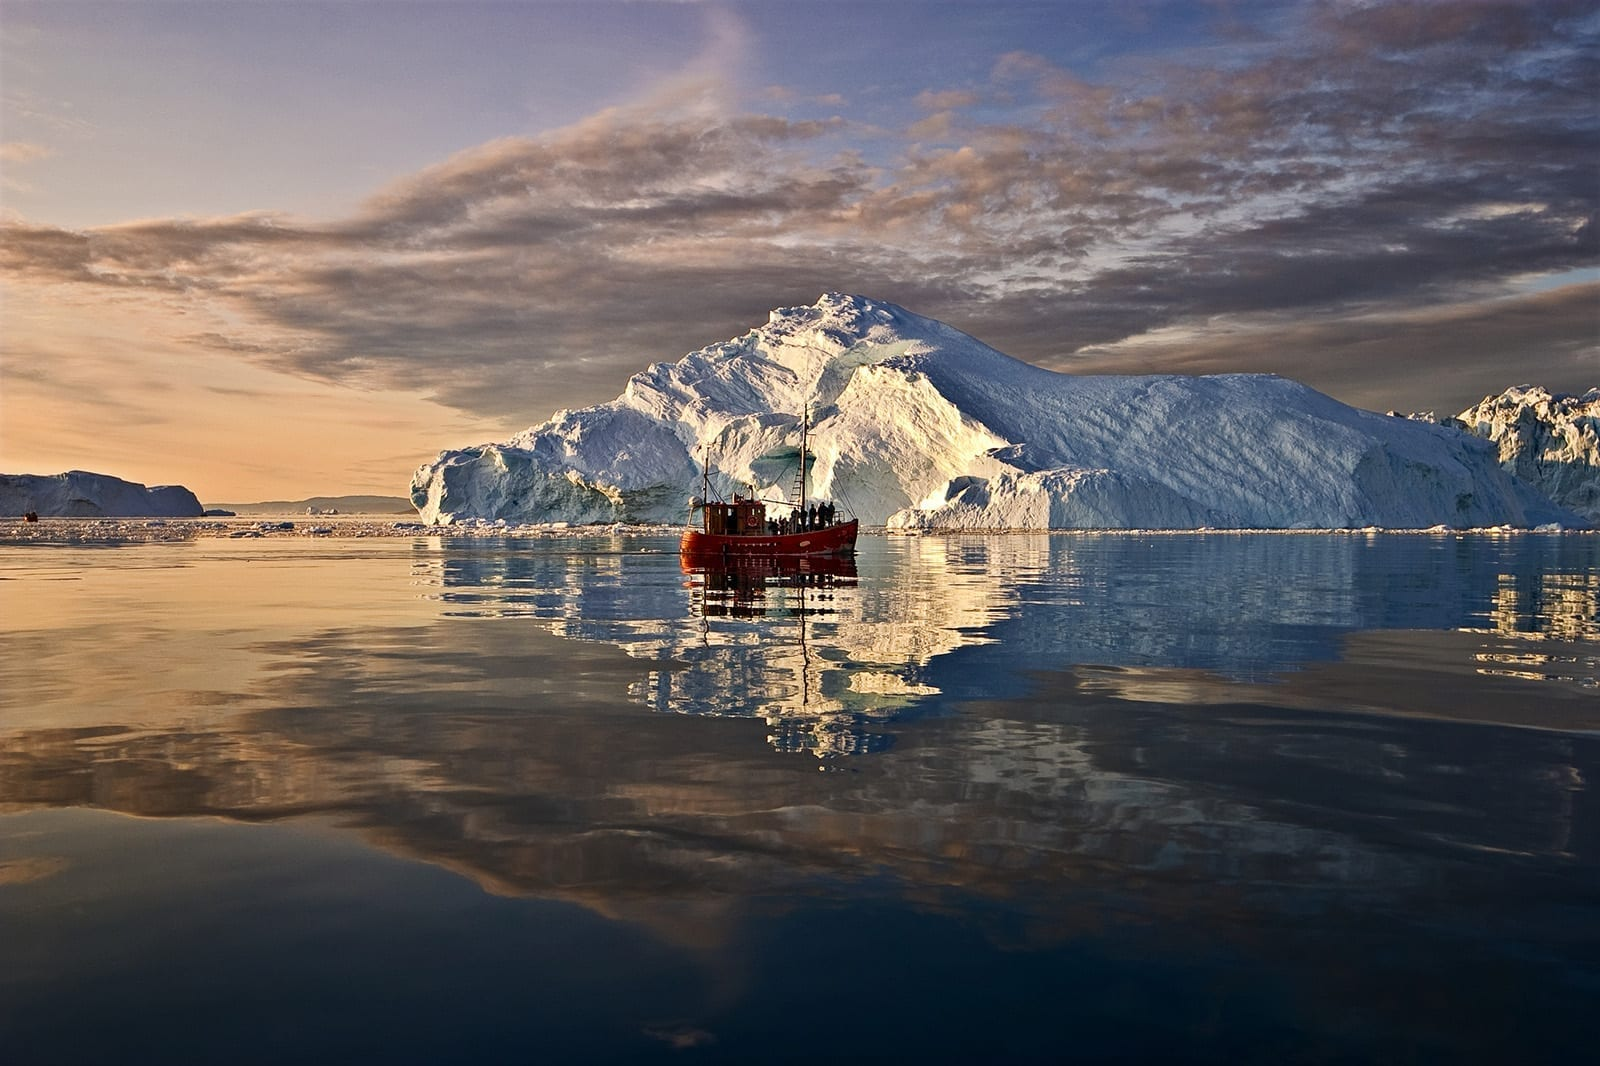What do you think is going on in this snapshot? This snapshot presents a serene moment at the Ilulissat Icefjord, located on the west coast of Greenland. As a UNESCO World Heritage Site, it is famous for its icebergs that are calved from the most productive glacier in the Northern Hemisphere, Sermeq Kujalleq. The mirror-like water reflects the majestic icebergs and the dynamic sky, creating a symphony of natural artwork. The presence of the red boat adds a vivid contrast to the predominantly blue and white scene, emphasizing the scale of the ice formations and providing a glimpse into human exploration and research activities in this remote area. This landscape is not only stunning visually but also of great importance for geologists and climate scientists studying the effects of global warming on glacial ice. 